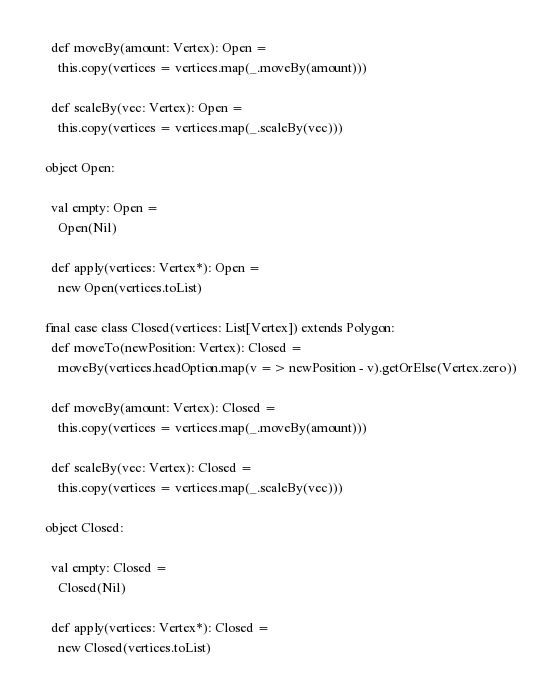Convert code to text. <code><loc_0><loc_0><loc_500><loc_500><_Scala_>    def moveBy(amount: Vertex): Open =
      this.copy(vertices = vertices.map(_.moveBy(amount)))

    def scaleBy(vec: Vertex): Open =
      this.copy(vertices = vertices.map(_.scaleBy(vec)))

  object Open:

    val empty: Open =
      Open(Nil)

    def apply(vertices: Vertex*): Open =
      new Open(vertices.toList)

  final case class Closed(vertices: List[Vertex]) extends Polygon:
    def moveTo(newPosition: Vertex): Closed =
      moveBy(vertices.headOption.map(v => newPosition - v).getOrElse(Vertex.zero))

    def moveBy(amount: Vertex): Closed =
      this.copy(vertices = vertices.map(_.moveBy(amount)))

    def scaleBy(vec: Vertex): Closed =
      this.copy(vertices = vertices.map(_.scaleBy(vec)))

  object Closed:

    val empty: Closed =
      Closed(Nil)

    def apply(vertices: Vertex*): Closed =
      new Closed(vertices.toList)
</code> 